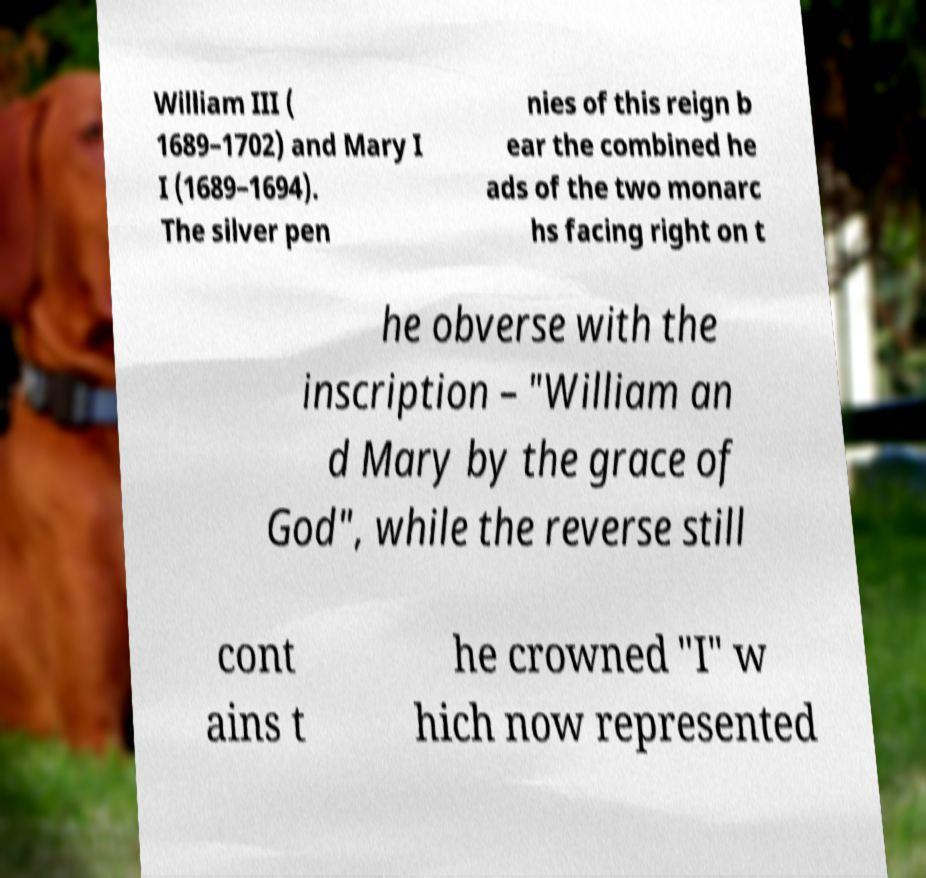Can you accurately transcribe the text from the provided image for me? William III ( 1689–1702) and Mary I I (1689–1694). The silver pen nies of this reign b ear the combined he ads of the two monarc hs facing right on t he obverse with the inscription – "William an d Mary by the grace of God", while the reverse still cont ains t he crowned "I" w hich now represented 